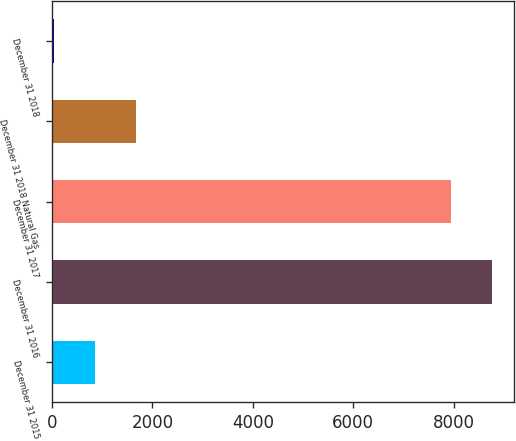Convert chart. <chart><loc_0><loc_0><loc_500><loc_500><bar_chart><fcel>December 31 2015<fcel>December 31 2016<fcel>December 31 2017<fcel>December 31 2018 Natural Gas<fcel>December 31 2018<nl><fcel>862.31<fcel>8754.41<fcel>7933<fcel>1683.72<fcel>40.9<nl></chart> 